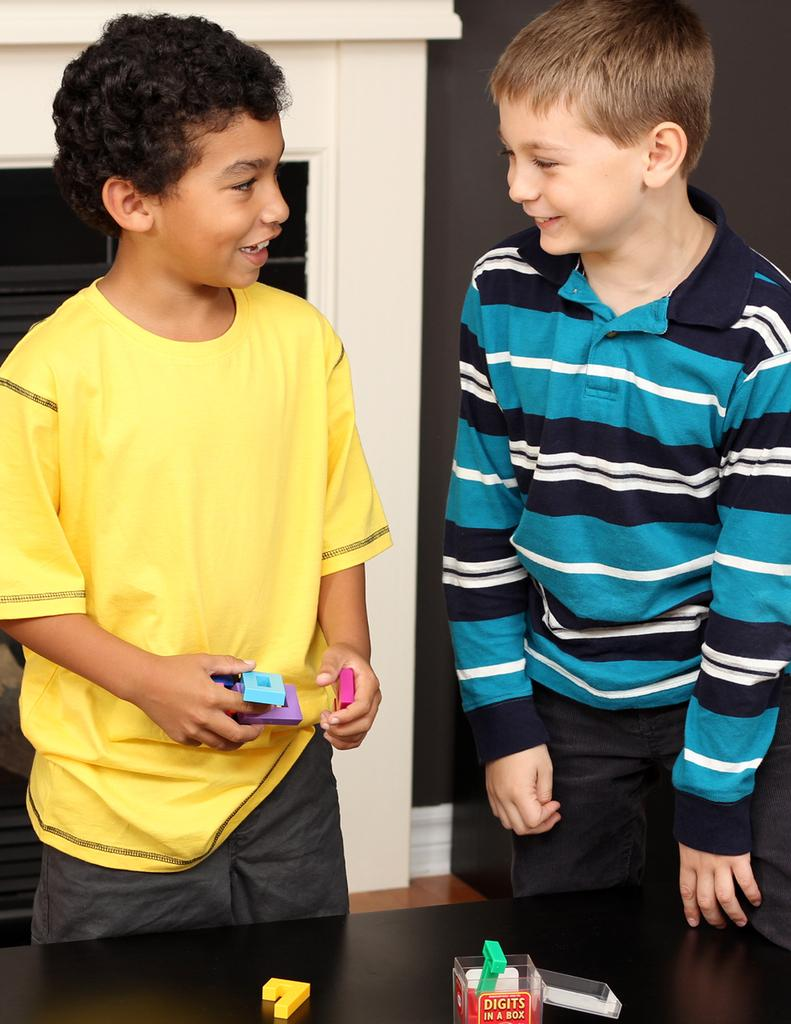How many kids are in the image? There are two kids in the foreground of the image. What are the kids doing in the image? The kids are standing on the floor. What is behind the kids in the image? The kids are in front of a table. What can be seen in the background of the image? There is a wall and a door in the background of the image. Where is the image taken? The image is taken in a room. What type of button can be seen on the jellyfish in the image? There are no jellyfish or buttons present in the image. 